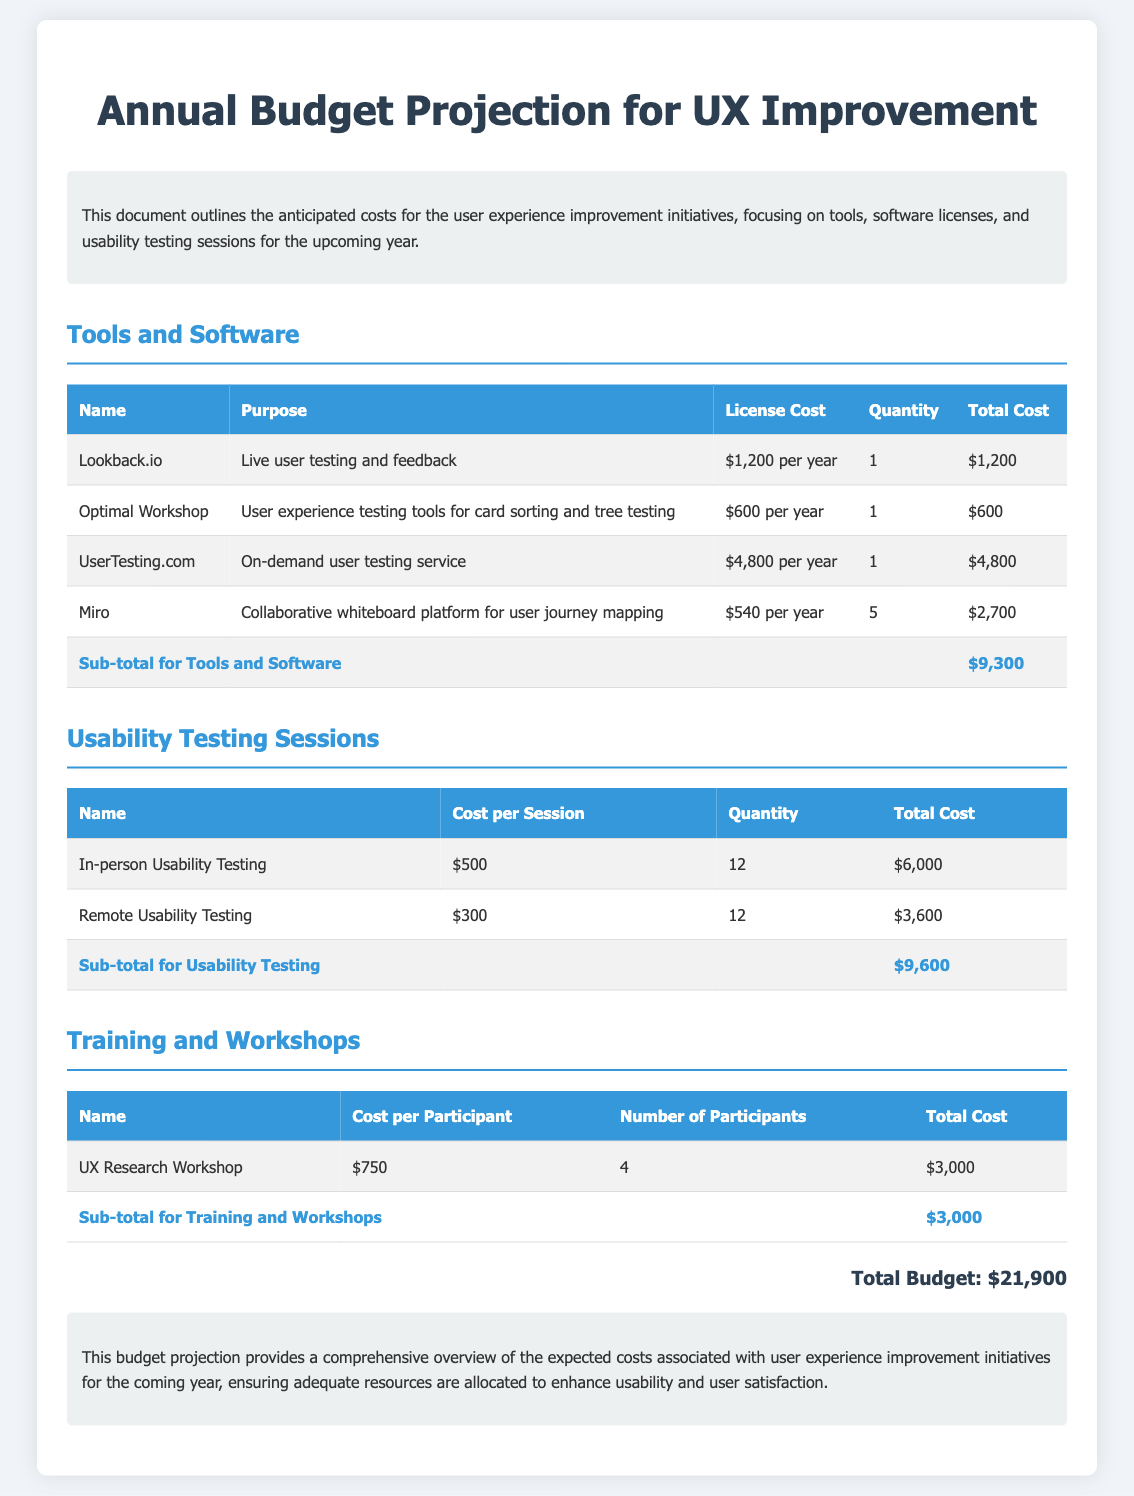What is the total budget for UX improvement initiatives? The total budget is calculated from all anticipated costs listed in the document, which sums up to $21,900.
Answer: $21,900 How many usability testing sessions are planned in total? The document specifies two types of usability testing sessions, totaling 12 in-person and 12 remote sessions, which adds up to 24 sessions.
Answer: 24 What is the cost per session for remote usability testing? The document states that remote usability testing costs $300 per session.
Answer: $300 Which tool is used for live user testing and feedback? The document lists Lookback.io as the tool for live user testing and feedback.
Answer: Lookback.io What is the sub-total for tools and software? The sum of all costs for tools and software provided in the document totals $9,300.
Answer: $9,300 How many participants are there for the UX Research Workshop? The document states that there are 4 participants for the UX Research Workshop.
Answer: 4 What is the cost of in-person usability testing per session? According to the document, in-person usability testing costs $500 per session.
Answer: $500 What is the purpose of using Miro? The document mentions that Miro is used for collaborative whiteboard platform for user journey mapping.
Answer: Collaborative whiteboard platform for user journey mapping What is the anticipated cost for training and workshops? The total cost for training and workshops as specified in the document is $3,000.
Answer: $3,000 